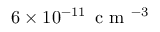Convert formula to latex. <formula><loc_0><loc_0><loc_500><loc_500>6 \times 1 0 ^ { - 1 1 } \, c m ^ { - 3 }</formula> 